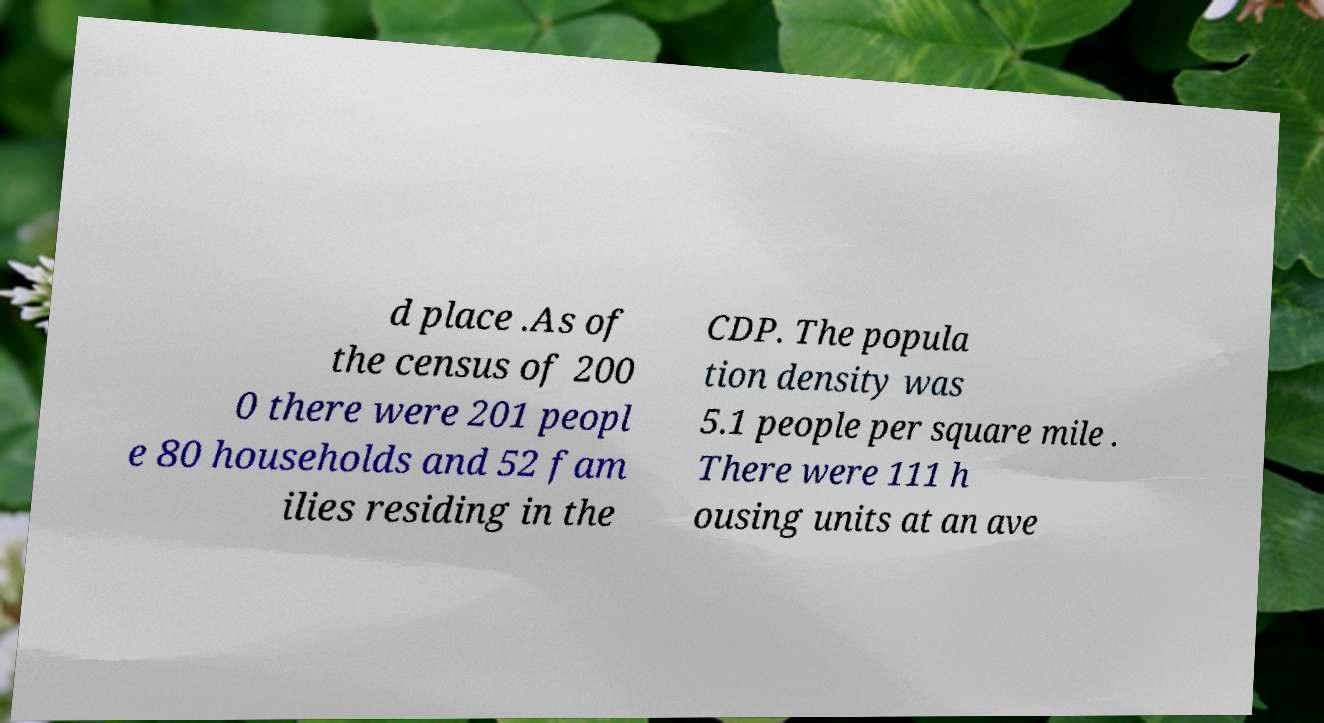Could you assist in decoding the text presented in this image and type it out clearly? d place .As of the census of 200 0 there were 201 peopl e 80 households and 52 fam ilies residing in the CDP. The popula tion density was 5.1 people per square mile . There were 111 h ousing units at an ave 